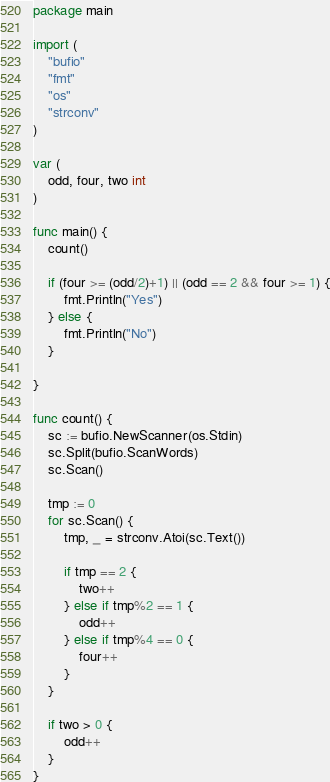<code> <loc_0><loc_0><loc_500><loc_500><_Go_>package main

import (
	"bufio"
	"fmt"
	"os"
	"strconv"
)

var (
	odd, four, two int
)

func main() {
	count()

	if (four >= (odd/2)+1) || (odd == 2 && four >= 1) {
		fmt.Println("Yes")
	} else {
		fmt.Println("No")
	}

}

func count() {
	sc := bufio.NewScanner(os.Stdin)
	sc.Split(bufio.ScanWords)
	sc.Scan()

	tmp := 0
	for sc.Scan() {
		tmp, _ = strconv.Atoi(sc.Text())

		if tmp == 2 {
			two++
		} else if tmp%2 == 1 {
			odd++
		} else if tmp%4 == 0 {
			four++
		}
	}

	if two > 0 {
		odd++
	}
}</code> 